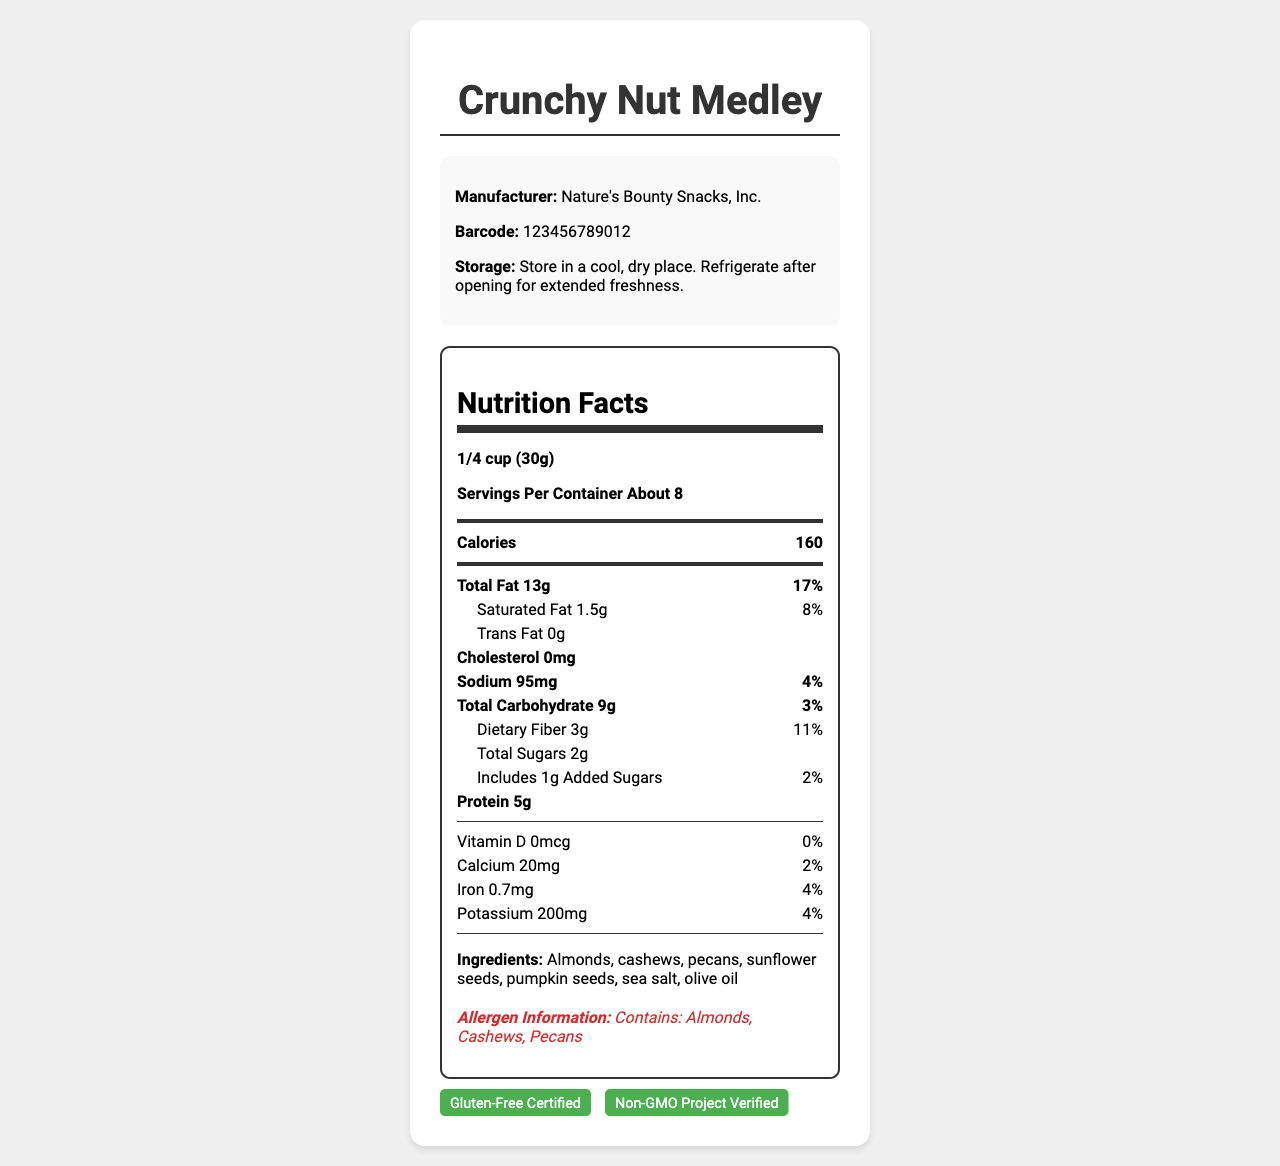how many calories are in one serving? The document states that each serving of "Crunchy Nut Medley" contains 160 calories.
Answer: 160 what is the serving size? The serving size for "Crunchy Nut Medley" is given as "1/4 cup (30g)".
Answer: 1/4 cup (30g) Is the product gluten-free? The document states that the product is gluten-free.
Answer: Yes who is the manufacturer? The document lists the manufacturer as "Nature's Bounty Snacks, Inc."
Answer: Nature's Bounty Snacks, Inc. how much sodium is in one serving? The document specifies that there are 95mg of sodium in one serving.
Answer: 95mg what are the main allergens in this product? A. Almonds, Peanuts, Cashews B. Almonds, Cashews, Pecans C. Almonds, Pecans, Walnuts D. Cashews, Walnuts, Pecans The document lists the allergens as "Almonds, Cashews, Pecans."
Answer: B what is the daily value percentage for saturated fat? I. 5% II. 8% III. 10% IV. 12% The document states that the daily value percentage for saturated fat is 8%.
Answer: II Does this product contain trans fat? The document specifies that there is 0g of trans fat in this product.
Answer: No summarize the nutrition and other key information provided about "Crunchy Nut Medley". This is a detailed description of the nutritional content, ingredients, manufacturer, and key notes about the product as presented in the document.
Answer: "Crunchy Nut Medley" is a gluten-free snack made by Nature's Bounty Snacks, Inc. Each serving size is 1/4 cup (30g) with about 8 servings per container. It contains 160 calories, 13g total fat (17% daily value), 1.5g saturated fat (8% daily value), 95mg sodium (4% daily value), 9g total carbohydrate (3% daily value), 3g dietary fiber (11% daily value), 2g total sugars including 1g added sugars (2% daily value), and 5g protein. The product does not contain cholesterol or trans fat. Allergen information includes almonds, cashews, and pecans. how much protein is there in one serving of Crunchy Nut Medley? The document specifies that there are 5 grams of protein in one serving of Crunchy Nut Medley.
Answer: 5g what certifications does this product have? The document displays the certifications as "Gluten-Free Certified" and "Non-GMO Project Verified".
Answer: Gluten-Free Certified, Non-GMO Project Verified what is the reorder point for this product? The reorder point for the product is listed as 20 in the POS system integration section.
Answer: 20 what is the contact information for the supplier? The supplier's contact information is listed as "orders@wholesalenuts.com".
Answer: orders@wholesalenuts.com what is the shelf placement for this product in the store? The retailer notes indicate that the product should be placed in the "Gluten-Free Snack Aisle."
Answer: Gluten-Free Snack Aisle what is the price point for this product? The price point for the product is listed as $5.99 in the retailer notes.
Answer: $5.99 what flavor is the snack? The document does not provide any information about the specific flavor of the snack.
Answer: Cannot be determined 